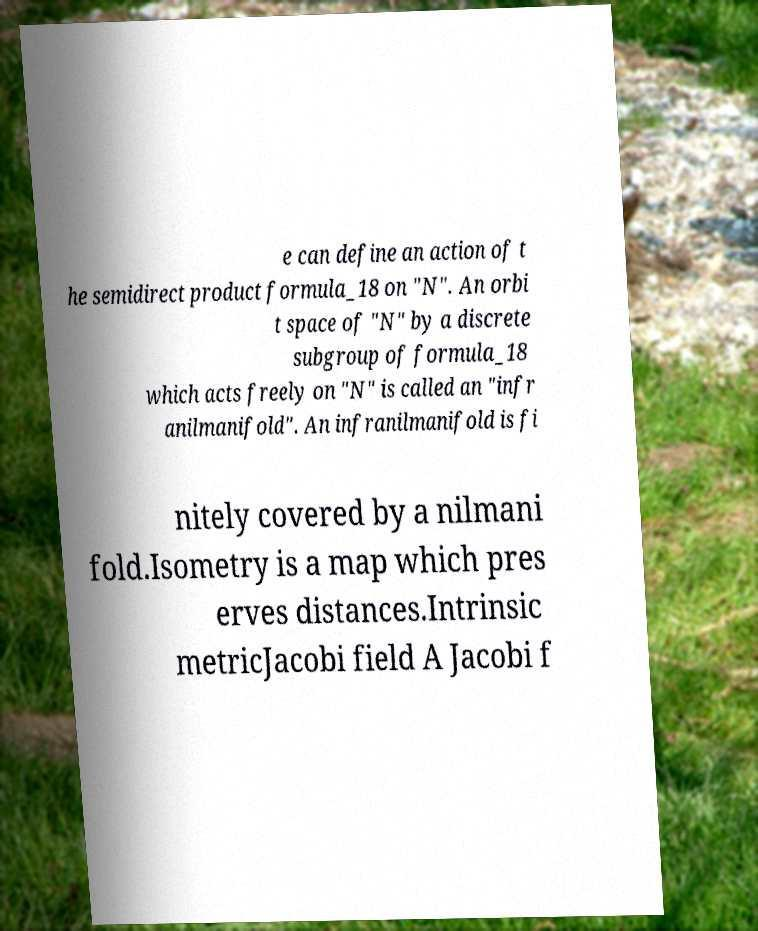I need the written content from this picture converted into text. Can you do that? e can define an action of t he semidirect product formula_18 on "N". An orbi t space of "N" by a discrete subgroup of formula_18 which acts freely on "N" is called an "infr anilmanifold". An infranilmanifold is fi nitely covered by a nilmani fold.Isometry is a map which pres erves distances.Intrinsic metricJacobi field A Jacobi f 